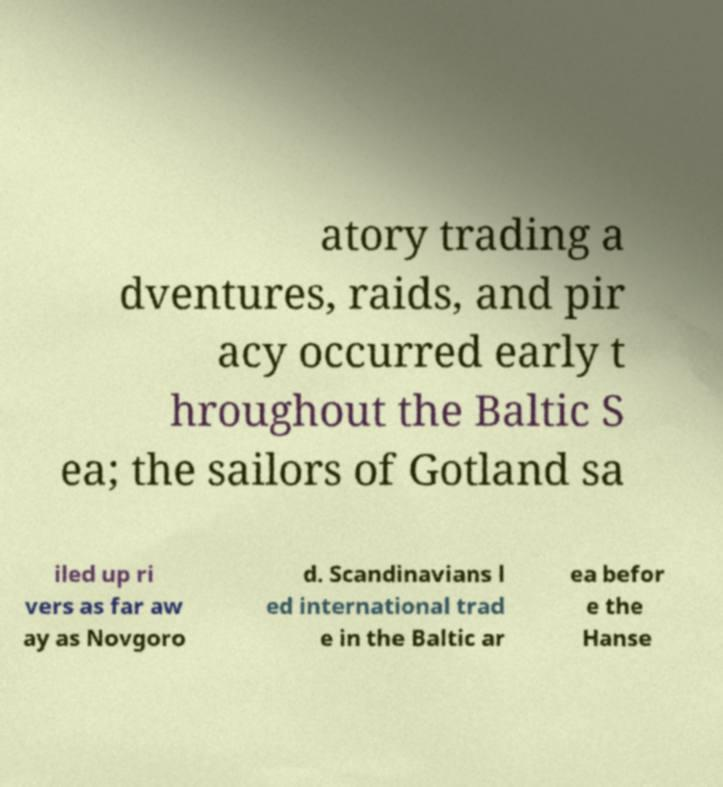Could you assist in decoding the text presented in this image and type it out clearly? atory trading a dventures, raids, and pir acy occurred early t hroughout the Baltic S ea; the sailors of Gotland sa iled up ri vers as far aw ay as Novgoro d. Scandinavians l ed international trad e in the Baltic ar ea befor e the Hanse 